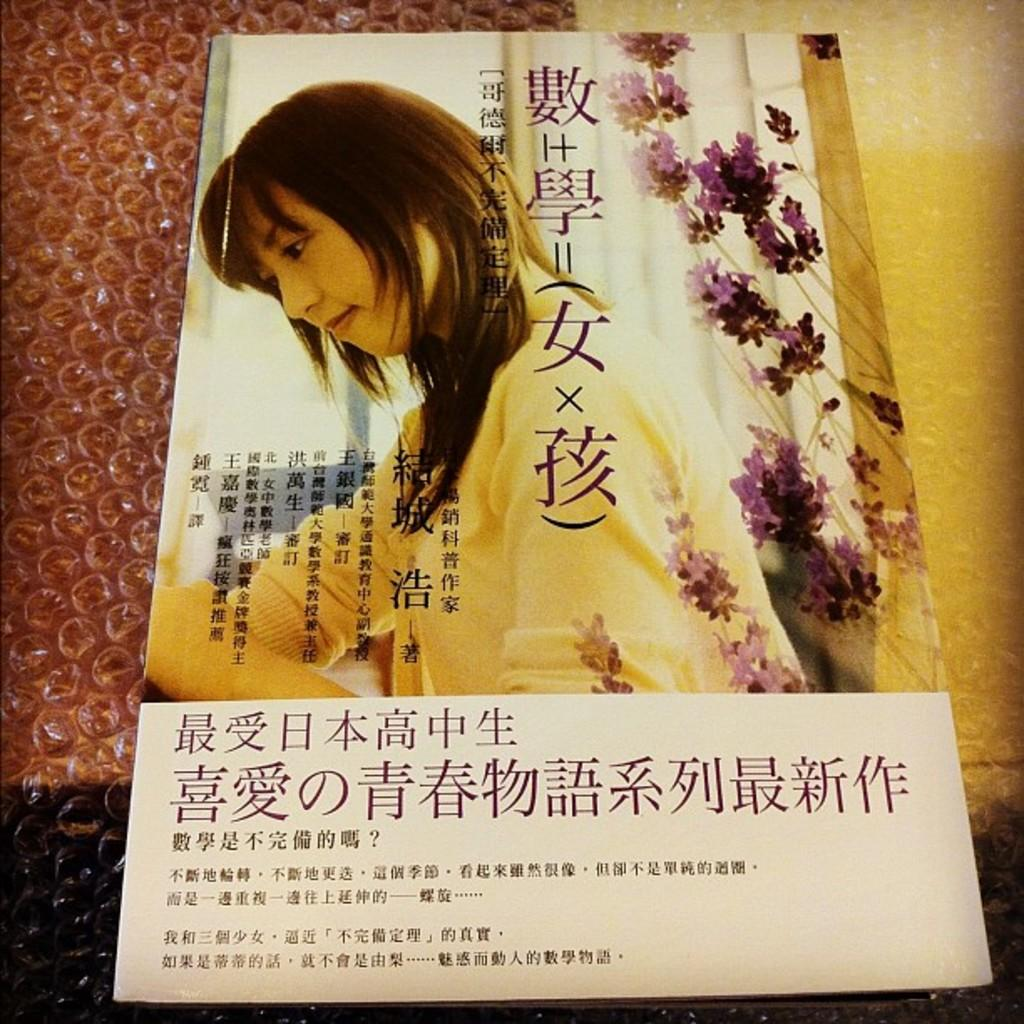What is the main object in the image? There is a poster in the image. What is the poster placed on? The poster is on an air bubble cover. What is depicted on the poster? The poster features a woman and includes flowers. Are there any words on the poster? Yes, there is text on the poster. Can you see the dad sleeping on the poster? There is no dad or any sleeping figure depicted on the poster; it features a woman and flowers. 